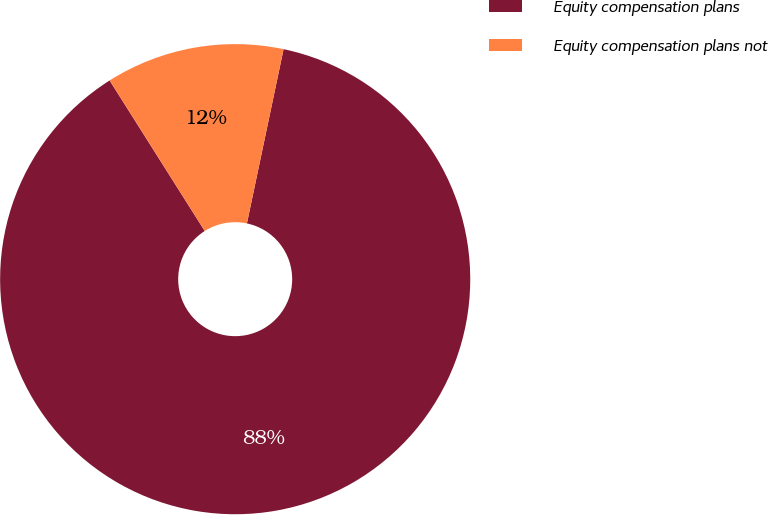<chart> <loc_0><loc_0><loc_500><loc_500><pie_chart><fcel>Equity compensation plans<fcel>Equity compensation plans not<nl><fcel>87.73%<fcel>12.27%<nl></chart> 